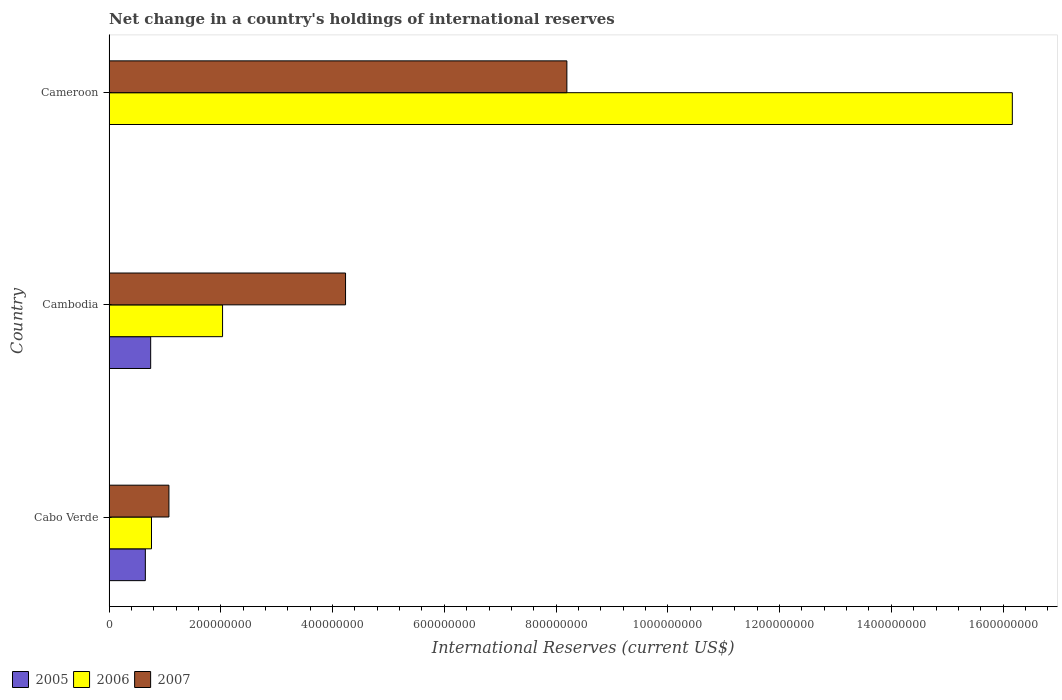How many different coloured bars are there?
Your answer should be compact. 3. How many groups of bars are there?
Your answer should be compact. 3. Are the number of bars per tick equal to the number of legend labels?
Make the answer very short. No. How many bars are there on the 2nd tick from the bottom?
Your answer should be compact. 3. What is the label of the 3rd group of bars from the top?
Your answer should be compact. Cabo Verde. What is the international reserves in 2005 in Cameroon?
Your answer should be very brief. 0. Across all countries, what is the maximum international reserves in 2006?
Offer a terse response. 1.62e+09. Across all countries, what is the minimum international reserves in 2006?
Ensure brevity in your answer.  7.60e+07. In which country was the international reserves in 2005 maximum?
Your response must be concise. Cambodia. What is the total international reserves in 2006 in the graph?
Offer a very short reply. 1.90e+09. What is the difference between the international reserves in 2007 in Cabo Verde and that in Cameroon?
Offer a terse response. -7.12e+08. What is the difference between the international reserves in 2007 in Cameroon and the international reserves in 2005 in Cabo Verde?
Keep it short and to the point. 7.54e+08. What is the average international reserves in 2005 per country?
Your response must be concise. 4.65e+07. What is the difference between the international reserves in 2006 and international reserves in 2005 in Cabo Verde?
Provide a succinct answer. 1.10e+07. What is the ratio of the international reserves in 2007 in Cabo Verde to that in Cambodia?
Offer a terse response. 0.25. Is the international reserves in 2007 in Cabo Verde less than that in Cameroon?
Your response must be concise. Yes. What is the difference between the highest and the second highest international reserves in 2007?
Provide a short and direct response. 3.96e+08. What is the difference between the highest and the lowest international reserves in 2007?
Make the answer very short. 7.12e+08. Is it the case that in every country, the sum of the international reserves in 2007 and international reserves in 2006 is greater than the international reserves in 2005?
Your answer should be compact. Yes. How many bars are there?
Provide a succinct answer. 8. How many countries are there in the graph?
Your answer should be very brief. 3. What is the difference between two consecutive major ticks on the X-axis?
Ensure brevity in your answer.  2.00e+08. Are the values on the major ticks of X-axis written in scientific E-notation?
Provide a short and direct response. No. Does the graph contain any zero values?
Ensure brevity in your answer.  Yes. Does the graph contain grids?
Your answer should be compact. No. Where does the legend appear in the graph?
Offer a terse response. Bottom left. How many legend labels are there?
Offer a terse response. 3. How are the legend labels stacked?
Provide a succinct answer. Horizontal. What is the title of the graph?
Your answer should be very brief. Net change in a country's holdings of international reserves. What is the label or title of the X-axis?
Make the answer very short. International Reserves (current US$). What is the International Reserves (current US$) in 2005 in Cabo Verde?
Offer a very short reply. 6.49e+07. What is the International Reserves (current US$) of 2006 in Cabo Verde?
Ensure brevity in your answer.  7.60e+07. What is the International Reserves (current US$) of 2007 in Cabo Verde?
Your answer should be very brief. 1.07e+08. What is the International Reserves (current US$) in 2005 in Cambodia?
Make the answer very short. 7.45e+07. What is the International Reserves (current US$) in 2006 in Cambodia?
Keep it short and to the point. 2.03e+08. What is the International Reserves (current US$) of 2007 in Cambodia?
Your answer should be compact. 4.23e+08. What is the International Reserves (current US$) in 2005 in Cameroon?
Keep it short and to the point. 0. What is the International Reserves (current US$) in 2006 in Cameroon?
Provide a succinct answer. 1.62e+09. What is the International Reserves (current US$) in 2007 in Cameroon?
Provide a succinct answer. 8.19e+08. Across all countries, what is the maximum International Reserves (current US$) of 2005?
Offer a terse response. 7.45e+07. Across all countries, what is the maximum International Reserves (current US$) of 2006?
Your answer should be compact. 1.62e+09. Across all countries, what is the maximum International Reserves (current US$) of 2007?
Make the answer very short. 8.19e+08. Across all countries, what is the minimum International Reserves (current US$) of 2005?
Make the answer very short. 0. Across all countries, what is the minimum International Reserves (current US$) in 2006?
Your response must be concise. 7.60e+07. Across all countries, what is the minimum International Reserves (current US$) in 2007?
Provide a succinct answer. 1.07e+08. What is the total International Reserves (current US$) of 2005 in the graph?
Your response must be concise. 1.39e+08. What is the total International Reserves (current US$) of 2006 in the graph?
Your answer should be very brief. 1.90e+09. What is the total International Reserves (current US$) in 2007 in the graph?
Your answer should be compact. 1.35e+09. What is the difference between the International Reserves (current US$) in 2005 in Cabo Verde and that in Cambodia?
Ensure brevity in your answer.  -9.54e+06. What is the difference between the International Reserves (current US$) of 2006 in Cabo Verde and that in Cambodia?
Keep it short and to the point. -1.27e+08. What is the difference between the International Reserves (current US$) in 2007 in Cabo Verde and that in Cambodia?
Provide a succinct answer. -3.16e+08. What is the difference between the International Reserves (current US$) in 2006 in Cabo Verde and that in Cameroon?
Your answer should be compact. -1.54e+09. What is the difference between the International Reserves (current US$) of 2007 in Cabo Verde and that in Cameroon?
Your answer should be compact. -7.12e+08. What is the difference between the International Reserves (current US$) in 2006 in Cambodia and that in Cameroon?
Provide a succinct answer. -1.41e+09. What is the difference between the International Reserves (current US$) in 2007 in Cambodia and that in Cameroon?
Provide a succinct answer. -3.96e+08. What is the difference between the International Reserves (current US$) in 2005 in Cabo Verde and the International Reserves (current US$) in 2006 in Cambodia?
Your answer should be compact. -1.38e+08. What is the difference between the International Reserves (current US$) of 2005 in Cabo Verde and the International Reserves (current US$) of 2007 in Cambodia?
Offer a very short reply. -3.58e+08. What is the difference between the International Reserves (current US$) in 2006 in Cabo Verde and the International Reserves (current US$) in 2007 in Cambodia?
Your response must be concise. -3.47e+08. What is the difference between the International Reserves (current US$) in 2005 in Cabo Verde and the International Reserves (current US$) in 2006 in Cameroon?
Give a very brief answer. -1.55e+09. What is the difference between the International Reserves (current US$) in 2005 in Cabo Verde and the International Reserves (current US$) in 2007 in Cameroon?
Your answer should be compact. -7.54e+08. What is the difference between the International Reserves (current US$) in 2006 in Cabo Verde and the International Reserves (current US$) in 2007 in Cameroon?
Provide a succinct answer. -7.43e+08. What is the difference between the International Reserves (current US$) of 2005 in Cambodia and the International Reserves (current US$) of 2006 in Cameroon?
Provide a succinct answer. -1.54e+09. What is the difference between the International Reserves (current US$) in 2005 in Cambodia and the International Reserves (current US$) in 2007 in Cameroon?
Offer a terse response. -7.45e+08. What is the difference between the International Reserves (current US$) in 2006 in Cambodia and the International Reserves (current US$) in 2007 in Cameroon?
Give a very brief answer. -6.16e+08. What is the average International Reserves (current US$) of 2005 per country?
Make the answer very short. 4.65e+07. What is the average International Reserves (current US$) of 2006 per country?
Your answer should be compact. 6.32e+08. What is the average International Reserves (current US$) in 2007 per country?
Offer a very short reply. 4.50e+08. What is the difference between the International Reserves (current US$) in 2005 and International Reserves (current US$) in 2006 in Cabo Verde?
Provide a short and direct response. -1.10e+07. What is the difference between the International Reserves (current US$) of 2005 and International Reserves (current US$) of 2007 in Cabo Verde?
Provide a short and direct response. -4.22e+07. What is the difference between the International Reserves (current US$) in 2006 and International Reserves (current US$) in 2007 in Cabo Verde?
Provide a succinct answer. -3.12e+07. What is the difference between the International Reserves (current US$) of 2005 and International Reserves (current US$) of 2006 in Cambodia?
Give a very brief answer. -1.29e+08. What is the difference between the International Reserves (current US$) in 2005 and International Reserves (current US$) in 2007 in Cambodia?
Ensure brevity in your answer.  -3.49e+08. What is the difference between the International Reserves (current US$) in 2006 and International Reserves (current US$) in 2007 in Cambodia?
Provide a short and direct response. -2.20e+08. What is the difference between the International Reserves (current US$) in 2006 and International Reserves (current US$) in 2007 in Cameroon?
Provide a short and direct response. 7.97e+08. What is the ratio of the International Reserves (current US$) in 2005 in Cabo Verde to that in Cambodia?
Your answer should be very brief. 0.87. What is the ratio of the International Reserves (current US$) in 2006 in Cabo Verde to that in Cambodia?
Your response must be concise. 0.37. What is the ratio of the International Reserves (current US$) of 2007 in Cabo Verde to that in Cambodia?
Your response must be concise. 0.25. What is the ratio of the International Reserves (current US$) of 2006 in Cabo Verde to that in Cameroon?
Your response must be concise. 0.05. What is the ratio of the International Reserves (current US$) of 2007 in Cabo Verde to that in Cameroon?
Provide a short and direct response. 0.13. What is the ratio of the International Reserves (current US$) in 2006 in Cambodia to that in Cameroon?
Ensure brevity in your answer.  0.13. What is the ratio of the International Reserves (current US$) in 2007 in Cambodia to that in Cameroon?
Make the answer very short. 0.52. What is the difference between the highest and the second highest International Reserves (current US$) in 2006?
Keep it short and to the point. 1.41e+09. What is the difference between the highest and the second highest International Reserves (current US$) in 2007?
Ensure brevity in your answer.  3.96e+08. What is the difference between the highest and the lowest International Reserves (current US$) in 2005?
Offer a terse response. 7.45e+07. What is the difference between the highest and the lowest International Reserves (current US$) of 2006?
Your answer should be very brief. 1.54e+09. What is the difference between the highest and the lowest International Reserves (current US$) of 2007?
Offer a very short reply. 7.12e+08. 